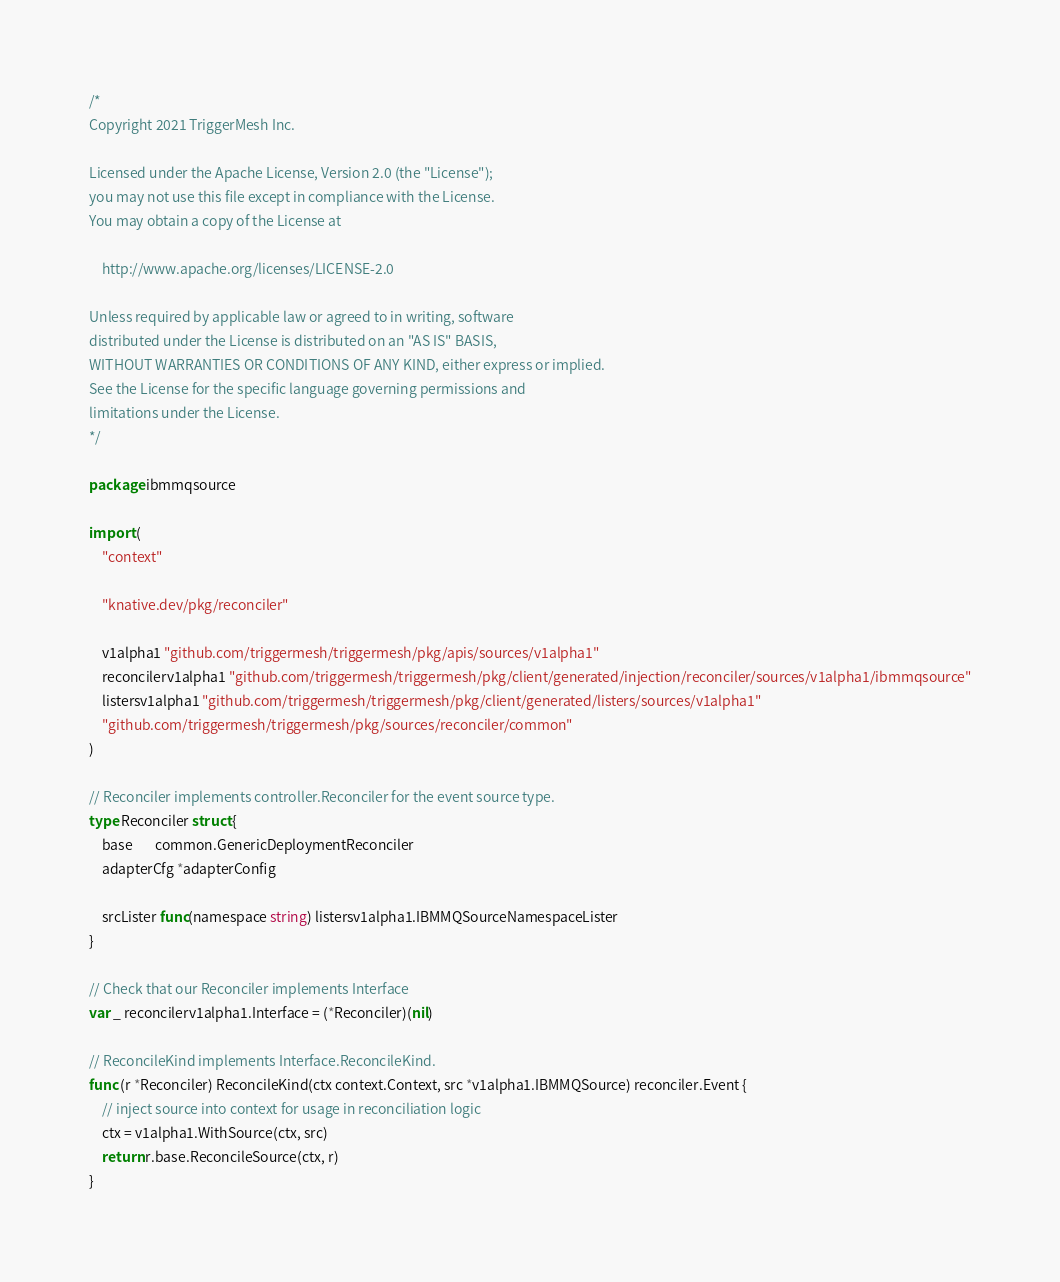Convert code to text. <code><loc_0><loc_0><loc_500><loc_500><_Go_>/*
Copyright 2021 TriggerMesh Inc.

Licensed under the Apache License, Version 2.0 (the "License");
you may not use this file except in compliance with the License.
You may obtain a copy of the License at

    http://www.apache.org/licenses/LICENSE-2.0

Unless required by applicable law or agreed to in writing, software
distributed under the License is distributed on an "AS IS" BASIS,
WITHOUT WARRANTIES OR CONDITIONS OF ANY KIND, either express or implied.
See the License for the specific language governing permissions and
limitations under the License.
*/

package ibmmqsource

import (
	"context"

	"knative.dev/pkg/reconciler"

	v1alpha1 "github.com/triggermesh/triggermesh/pkg/apis/sources/v1alpha1"
	reconcilerv1alpha1 "github.com/triggermesh/triggermesh/pkg/client/generated/injection/reconciler/sources/v1alpha1/ibmmqsource"
	listersv1alpha1 "github.com/triggermesh/triggermesh/pkg/client/generated/listers/sources/v1alpha1"
	"github.com/triggermesh/triggermesh/pkg/sources/reconciler/common"
)

// Reconciler implements controller.Reconciler for the event source type.
type Reconciler struct {
	base       common.GenericDeploymentReconciler
	adapterCfg *adapterConfig

	srcLister func(namespace string) listersv1alpha1.IBMMQSourceNamespaceLister
}

// Check that our Reconciler implements Interface
var _ reconcilerv1alpha1.Interface = (*Reconciler)(nil)

// ReconcileKind implements Interface.ReconcileKind.
func (r *Reconciler) ReconcileKind(ctx context.Context, src *v1alpha1.IBMMQSource) reconciler.Event {
	// inject source into context for usage in reconciliation logic
	ctx = v1alpha1.WithSource(ctx, src)
	return r.base.ReconcileSource(ctx, r)
}
</code> 